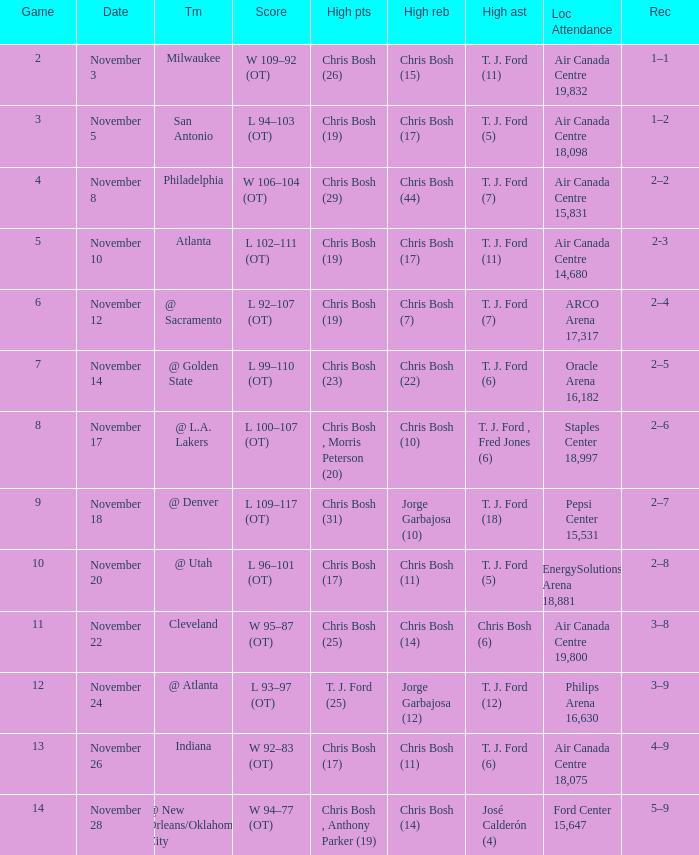What was the score of the game on November 12? L 92–107 (OT). 